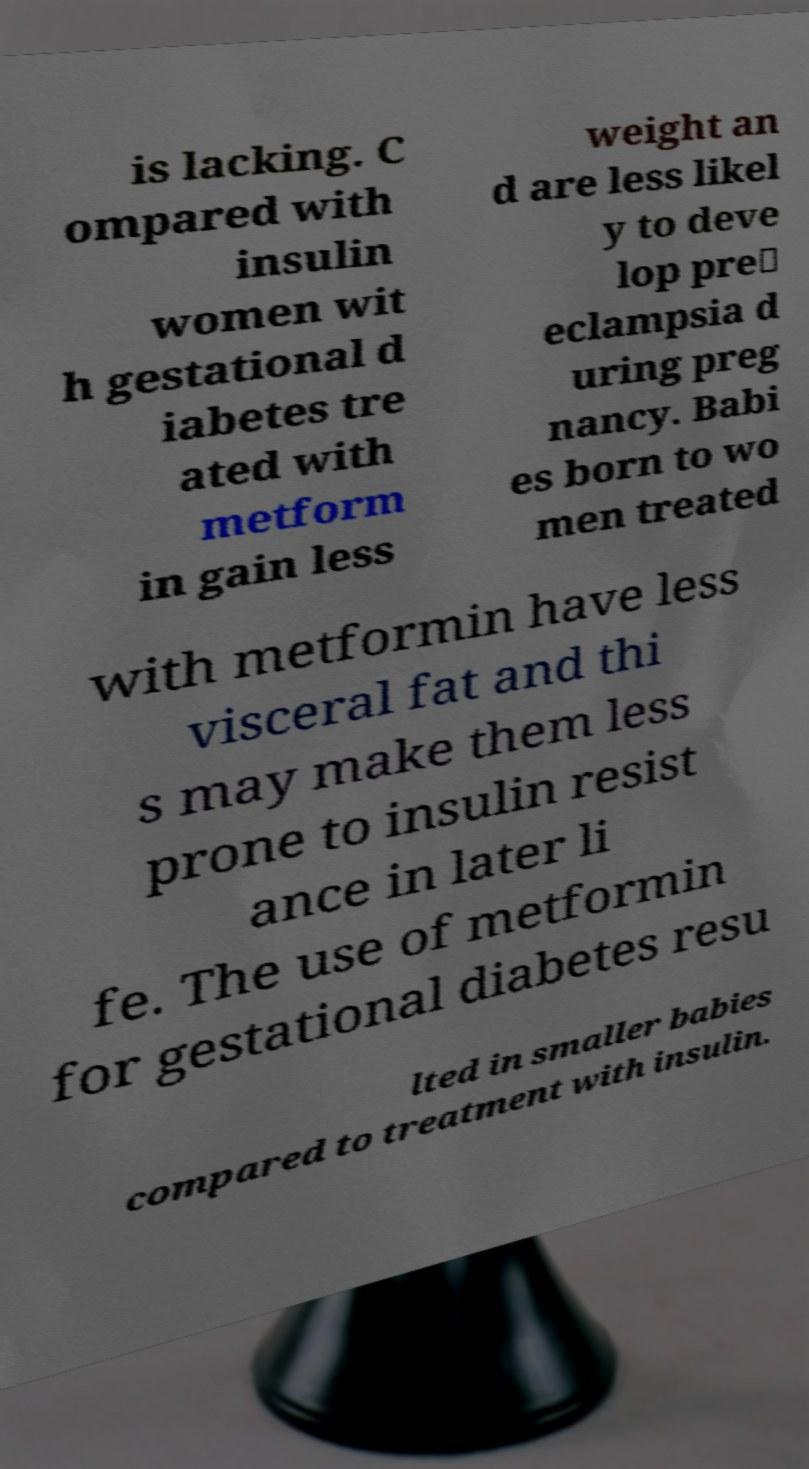Could you extract and type out the text from this image? is lacking. C ompared with insulin women wit h gestational d iabetes tre ated with metform in gain less weight an d are less likel y to deve lop pre‐ eclampsia d uring preg nancy. Babi es born to wo men treated with metformin have less visceral fat and thi s may make them less prone to insulin resist ance in later li fe. The use of metformin for gestational diabetes resu lted in smaller babies compared to treatment with insulin. 